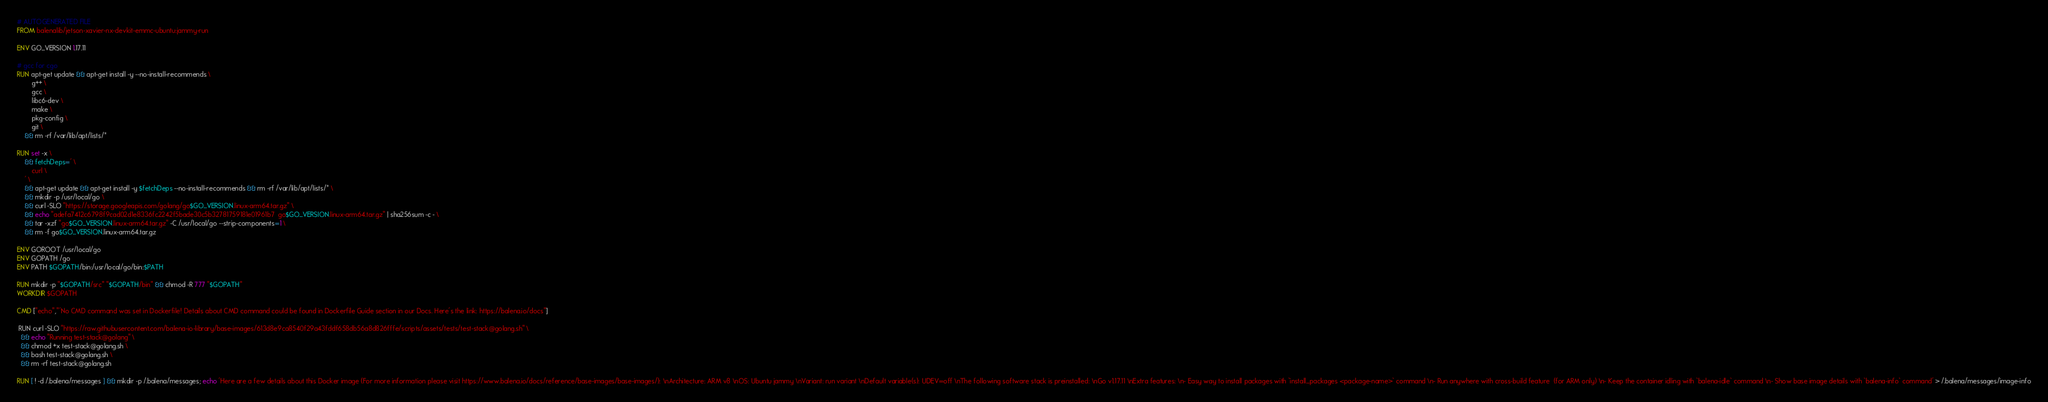<code> <loc_0><loc_0><loc_500><loc_500><_Dockerfile_># AUTOGENERATED FILE
FROM balenalib/jetson-xavier-nx-devkit-emmc-ubuntu:jammy-run

ENV GO_VERSION 1.17.11

# gcc for cgo
RUN apt-get update && apt-get install -y --no-install-recommends \
		g++ \
		gcc \
		libc6-dev \
		make \
		pkg-config \
		git \
	&& rm -rf /var/lib/apt/lists/*

RUN set -x \
	&& fetchDeps=' \
		curl \
	' \
	&& apt-get update && apt-get install -y $fetchDeps --no-install-recommends && rm -rf /var/lib/apt/lists/* \
	&& mkdir -p /usr/local/go \
	&& curl -SLO "https://storage.googleapis.com/golang/go$GO_VERSION.linux-arm64.tar.gz" \
	&& echo "adefa7412c6798f9cad02d1e8336fc2242f5bade30c5b32781759181e01961b7  go$GO_VERSION.linux-arm64.tar.gz" | sha256sum -c - \
	&& tar -xzf "go$GO_VERSION.linux-arm64.tar.gz" -C /usr/local/go --strip-components=1 \
	&& rm -f go$GO_VERSION.linux-arm64.tar.gz

ENV GOROOT /usr/local/go
ENV GOPATH /go
ENV PATH $GOPATH/bin:/usr/local/go/bin:$PATH

RUN mkdir -p "$GOPATH/src" "$GOPATH/bin" && chmod -R 777 "$GOPATH"
WORKDIR $GOPATH

CMD ["echo","'No CMD command was set in Dockerfile! Details about CMD command could be found in Dockerfile Guide section in our Docs. Here's the link: https://balena.io/docs"]

 RUN curl -SLO "https://raw.githubusercontent.com/balena-io-library/base-images/613d8e9ca8540f29a43fddf658db56a8d826fffe/scripts/assets/tests/test-stack@golang.sh" \
  && echo "Running test-stack@golang" \
  && chmod +x test-stack@golang.sh \
  && bash test-stack@golang.sh \
  && rm -rf test-stack@golang.sh 

RUN [ ! -d /.balena/messages ] && mkdir -p /.balena/messages; echo 'Here are a few details about this Docker image (For more information please visit https://www.balena.io/docs/reference/base-images/base-images/): \nArchitecture: ARM v8 \nOS: Ubuntu jammy \nVariant: run variant \nDefault variable(s): UDEV=off \nThe following software stack is preinstalled: \nGo v1.17.11 \nExtra features: \n- Easy way to install packages with `install_packages <package-name>` command \n- Run anywhere with cross-build feature  (for ARM only) \n- Keep the container idling with `balena-idle` command \n- Show base image details with `balena-info` command' > /.balena/messages/image-info</code> 